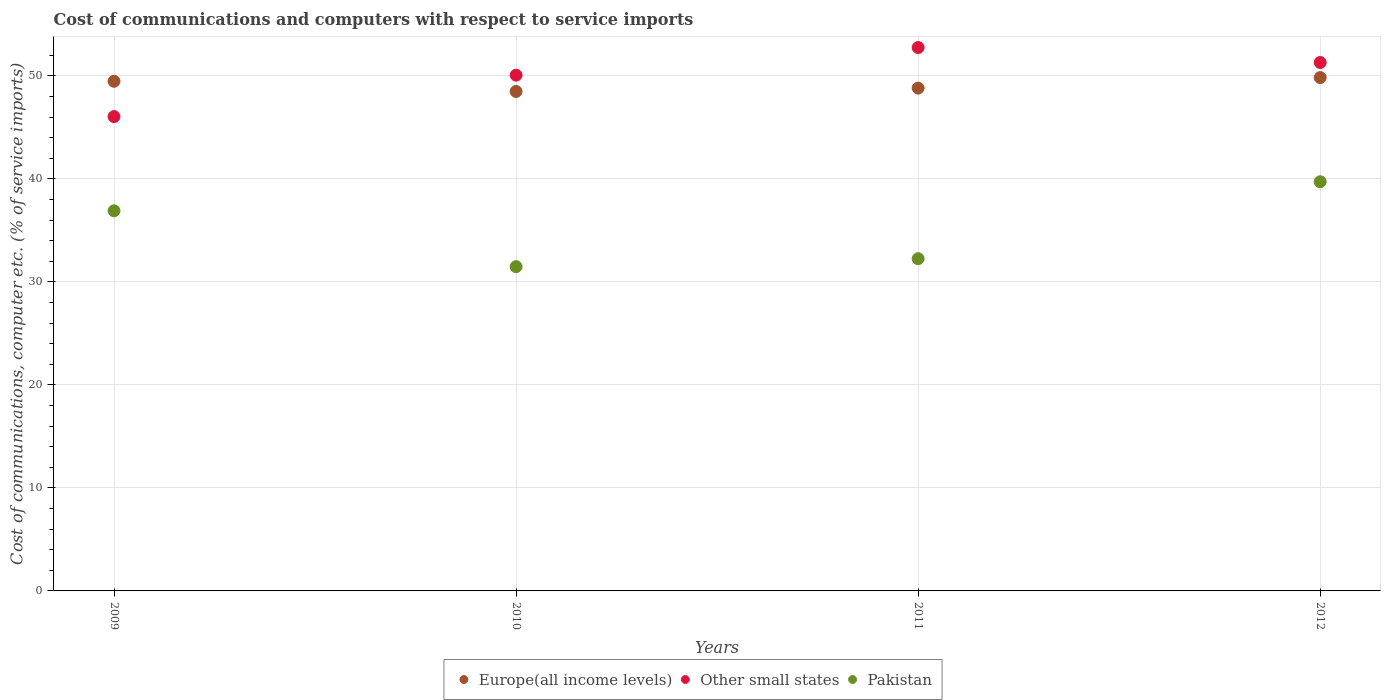Is the number of dotlines equal to the number of legend labels?
Your answer should be very brief. Yes. What is the cost of communications and computers in Other small states in 2010?
Your response must be concise. 50.07. Across all years, what is the maximum cost of communications and computers in Pakistan?
Make the answer very short. 39.73. Across all years, what is the minimum cost of communications and computers in Pakistan?
Make the answer very short. 31.48. In which year was the cost of communications and computers in Europe(all income levels) maximum?
Your response must be concise. 2012. What is the total cost of communications and computers in Other small states in the graph?
Offer a very short reply. 200.19. What is the difference between the cost of communications and computers in Europe(all income levels) in 2011 and that in 2012?
Ensure brevity in your answer.  -1.02. What is the difference between the cost of communications and computers in Other small states in 2010 and the cost of communications and computers in Europe(all income levels) in 2012?
Provide a succinct answer. 0.23. What is the average cost of communications and computers in Pakistan per year?
Your answer should be very brief. 35.09. In the year 2010, what is the difference between the cost of communications and computers in Europe(all income levels) and cost of communications and computers in Other small states?
Provide a short and direct response. -1.58. In how many years, is the cost of communications and computers in Europe(all income levels) greater than 20 %?
Offer a very short reply. 4. What is the ratio of the cost of communications and computers in Europe(all income levels) in 2010 to that in 2011?
Keep it short and to the point. 0.99. What is the difference between the highest and the second highest cost of communications and computers in Other small states?
Your answer should be very brief. 1.45. What is the difference between the highest and the lowest cost of communications and computers in Pakistan?
Offer a very short reply. 8.24. Is it the case that in every year, the sum of the cost of communications and computers in Europe(all income levels) and cost of communications and computers in Other small states  is greater than the cost of communications and computers in Pakistan?
Provide a succinct answer. Yes. Is the cost of communications and computers in Europe(all income levels) strictly less than the cost of communications and computers in Other small states over the years?
Your response must be concise. No. What is the difference between two consecutive major ticks on the Y-axis?
Provide a short and direct response. 10. Are the values on the major ticks of Y-axis written in scientific E-notation?
Ensure brevity in your answer.  No. Does the graph contain any zero values?
Offer a terse response. No. How many legend labels are there?
Give a very brief answer. 3. What is the title of the graph?
Provide a short and direct response. Cost of communications and computers with respect to service imports. Does "Ghana" appear as one of the legend labels in the graph?
Offer a terse response. No. What is the label or title of the X-axis?
Keep it short and to the point. Years. What is the label or title of the Y-axis?
Your answer should be compact. Cost of communications, computer etc. (% of service imports). What is the Cost of communications, computer etc. (% of service imports) in Europe(all income levels) in 2009?
Keep it short and to the point. 49.48. What is the Cost of communications, computer etc. (% of service imports) in Other small states in 2009?
Your response must be concise. 46.05. What is the Cost of communications, computer etc. (% of service imports) in Pakistan in 2009?
Offer a very short reply. 36.91. What is the Cost of communications, computer etc. (% of service imports) of Europe(all income levels) in 2010?
Ensure brevity in your answer.  48.49. What is the Cost of communications, computer etc. (% of service imports) in Other small states in 2010?
Your answer should be compact. 50.07. What is the Cost of communications, computer etc. (% of service imports) of Pakistan in 2010?
Make the answer very short. 31.48. What is the Cost of communications, computer etc. (% of service imports) of Europe(all income levels) in 2011?
Your answer should be very brief. 48.82. What is the Cost of communications, computer etc. (% of service imports) in Other small states in 2011?
Ensure brevity in your answer.  52.76. What is the Cost of communications, computer etc. (% of service imports) of Pakistan in 2011?
Offer a terse response. 32.26. What is the Cost of communications, computer etc. (% of service imports) of Europe(all income levels) in 2012?
Your answer should be very brief. 49.84. What is the Cost of communications, computer etc. (% of service imports) in Other small states in 2012?
Offer a terse response. 51.31. What is the Cost of communications, computer etc. (% of service imports) of Pakistan in 2012?
Your answer should be very brief. 39.73. Across all years, what is the maximum Cost of communications, computer etc. (% of service imports) of Europe(all income levels)?
Ensure brevity in your answer.  49.84. Across all years, what is the maximum Cost of communications, computer etc. (% of service imports) of Other small states?
Your answer should be compact. 52.76. Across all years, what is the maximum Cost of communications, computer etc. (% of service imports) in Pakistan?
Your answer should be compact. 39.73. Across all years, what is the minimum Cost of communications, computer etc. (% of service imports) in Europe(all income levels)?
Offer a terse response. 48.49. Across all years, what is the minimum Cost of communications, computer etc. (% of service imports) in Other small states?
Keep it short and to the point. 46.05. Across all years, what is the minimum Cost of communications, computer etc. (% of service imports) of Pakistan?
Your response must be concise. 31.48. What is the total Cost of communications, computer etc. (% of service imports) of Europe(all income levels) in the graph?
Offer a terse response. 196.64. What is the total Cost of communications, computer etc. (% of service imports) in Other small states in the graph?
Ensure brevity in your answer.  200.19. What is the total Cost of communications, computer etc. (% of service imports) of Pakistan in the graph?
Your response must be concise. 140.38. What is the difference between the Cost of communications, computer etc. (% of service imports) of Europe(all income levels) in 2009 and that in 2010?
Keep it short and to the point. 0.99. What is the difference between the Cost of communications, computer etc. (% of service imports) of Other small states in 2009 and that in 2010?
Provide a short and direct response. -4.02. What is the difference between the Cost of communications, computer etc. (% of service imports) in Pakistan in 2009 and that in 2010?
Provide a succinct answer. 5.42. What is the difference between the Cost of communications, computer etc. (% of service imports) in Europe(all income levels) in 2009 and that in 2011?
Keep it short and to the point. 0.66. What is the difference between the Cost of communications, computer etc. (% of service imports) of Other small states in 2009 and that in 2011?
Your answer should be compact. -6.7. What is the difference between the Cost of communications, computer etc. (% of service imports) of Pakistan in 2009 and that in 2011?
Make the answer very short. 4.65. What is the difference between the Cost of communications, computer etc. (% of service imports) in Europe(all income levels) in 2009 and that in 2012?
Your answer should be very brief. -0.36. What is the difference between the Cost of communications, computer etc. (% of service imports) in Other small states in 2009 and that in 2012?
Provide a succinct answer. -5.25. What is the difference between the Cost of communications, computer etc. (% of service imports) of Pakistan in 2009 and that in 2012?
Provide a succinct answer. -2.82. What is the difference between the Cost of communications, computer etc. (% of service imports) in Europe(all income levels) in 2010 and that in 2011?
Provide a short and direct response. -0.33. What is the difference between the Cost of communications, computer etc. (% of service imports) of Other small states in 2010 and that in 2011?
Provide a succinct answer. -2.68. What is the difference between the Cost of communications, computer etc. (% of service imports) of Pakistan in 2010 and that in 2011?
Keep it short and to the point. -0.77. What is the difference between the Cost of communications, computer etc. (% of service imports) of Europe(all income levels) in 2010 and that in 2012?
Make the answer very short. -1.35. What is the difference between the Cost of communications, computer etc. (% of service imports) in Other small states in 2010 and that in 2012?
Give a very brief answer. -1.23. What is the difference between the Cost of communications, computer etc. (% of service imports) in Pakistan in 2010 and that in 2012?
Offer a terse response. -8.24. What is the difference between the Cost of communications, computer etc. (% of service imports) in Europe(all income levels) in 2011 and that in 2012?
Offer a terse response. -1.02. What is the difference between the Cost of communications, computer etc. (% of service imports) in Other small states in 2011 and that in 2012?
Offer a very short reply. 1.45. What is the difference between the Cost of communications, computer etc. (% of service imports) in Pakistan in 2011 and that in 2012?
Keep it short and to the point. -7.47. What is the difference between the Cost of communications, computer etc. (% of service imports) of Europe(all income levels) in 2009 and the Cost of communications, computer etc. (% of service imports) of Other small states in 2010?
Your response must be concise. -0.59. What is the difference between the Cost of communications, computer etc. (% of service imports) in Europe(all income levels) in 2009 and the Cost of communications, computer etc. (% of service imports) in Pakistan in 2010?
Offer a terse response. 18. What is the difference between the Cost of communications, computer etc. (% of service imports) in Other small states in 2009 and the Cost of communications, computer etc. (% of service imports) in Pakistan in 2010?
Make the answer very short. 14.57. What is the difference between the Cost of communications, computer etc. (% of service imports) in Europe(all income levels) in 2009 and the Cost of communications, computer etc. (% of service imports) in Other small states in 2011?
Offer a very short reply. -3.28. What is the difference between the Cost of communications, computer etc. (% of service imports) in Europe(all income levels) in 2009 and the Cost of communications, computer etc. (% of service imports) in Pakistan in 2011?
Give a very brief answer. 17.22. What is the difference between the Cost of communications, computer etc. (% of service imports) of Other small states in 2009 and the Cost of communications, computer etc. (% of service imports) of Pakistan in 2011?
Make the answer very short. 13.8. What is the difference between the Cost of communications, computer etc. (% of service imports) in Europe(all income levels) in 2009 and the Cost of communications, computer etc. (% of service imports) in Other small states in 2012?
Keep it short and to the point. -1.82. What is the difference between the Cost of communications, computer etc. (% of service imports) of Europe(all income levels) in 2009 and the Cost of communications, computer etc. (% of service imports) of Pakistan in 2012?
Ensure brevity in your answer.  9.75. What is the difference between the Cost of communications, computer etc. (% of service imports) of Other small states in 2009 and the Cost of communications, computer etc. (% of service imports) of Pakistan in 2012?
Your answer should be very brief. 6.32. What is the difference between the Cost of communications, computer etc. (% of service imports) in Europe(all income levels) in 2010 and the Cost of communications, computer etc. (% of service imports) in Other small states in 2011?
Offer a very short reply. -4.27. What is the difference between the Cost of communications, computer etc. (% of service imports) of Europe(all income levels) in 2010 and the Cost of communications, computer etc. (% of service imports) of Pakistan in 2011?
Provide a short and direct response. 16.24. What is the difference between the Cost of communications, computer etc. (% of service imports) of Other small states in 2010 and the Cost of communications, computer etc. (% of service imports) of Pakistan in 2011?
Provide a succinct answer. 17.82. What is the difference between the Cost of communications, computer etc. (% of service imports) of Europe(all income levels) in 2010 and the Cost of communications, computer etc. (% of service imports) of Other small states in 2012?
Provide a succinct answer. -2.81. What is the difference between the Cost of communications, computer etc. (% of service imports) in Europe(all income levels) in 2010 and the Cost of communications, computer etc. (% of service imports) in Pakistan in 2012?
Ensure brevity in your answer.  8.76. What is the difference between the Cost of communications, computer etc. (% of service imports) in Other small states in 2010 and the Cost of communications, computer etc. (% of service imports) in Pakistan in 2012?
Make the answer very short. 10.35. What is the difference between the Cost of communications, computer etc. (% of service imports) of Europe(all income levels) in 2011 and the Cost of communications, computer etc. (% of service imports) of Other small states in 2012?
Offer a terse response. -2.49. What is the difference between the Cost of communications, computer etc. (% of service imports) of Europe(all income levels) in 2011 and the Cost of communications, computer etc. (% of service imports) of Pakistan in 2012?
Provide a succinct answer. 9.09. What is the difference between the Cost of communications, computer etc. (% of service imports) of Other small states in 2011 and the Cost of communications, computer etc. (% of service imports) of Pakistan in 2012?
Your answer should be compact. 13.03. What is the average Cost of communications, computer etc. (% of service imports) of Europe(all income levels) per year?
Give a very brief answer. 49.16. What is the average Cost of communications, computer etc. (% of service imports) of Other small states per year?
Ensure brevity in your answer.  50.05. What is the average Cost of communications, computer etc. (% of service imports) in Pakistan per year?
Your response must be concise. 35.09. In the year 2009, what is the difference between the Cost of communications, computer etc. (% of service imports) in Europe(all income levels) and Cost of communications, computer etc. (% of service imports) in Other small states?
Keep it short and to the point. 3.43. In the year 2009, what is the difference between the Cost of communications, computer etc. (% of service imports) in Europe(all income levels) and Cost of communications, computer etc. (% of service imports) in Pakistan?
Keep it short and to the point. 12.58. In the year 2009, what is the difference between the Cost of communications, computer etc. (% of service imports) of Other small states and Cost of communications, computer etc. (% of service imports) of Pakistan?
Your response must be concise. 9.15. In the year 2010, what is the difference between the Cost of communications, computer etc. (% of service imports) in Europe(all income levels) and Cost of communications, computer etc. (% of service imports) in Other small states?
Your answer should be compact. -1.58. In the year 2010, what is the difference between the Cost of communications, computer etc. (% of service imports) in Europe(all income levels) and Cost of communications, computer etc. (% of service imports) in Pakistan?
Your answer should be very brief. 17.01. In the year 2010, what is the difference between the Cost of communications, computer etc. (% of service imports) of Other small states and Cost of communications, computer etc. (% of service imports) of Pakistan?
Keep it short and to the point. 18.59. In the year 2011, what is the difference between the Cost of communications, computer etc. (% of service imports) in Europe(all income levels) and Cost of communications, computer etc. (% of service imports) in Other small states?
Offer a very short reply. -3.94. In the year 2011, what is the difference between the Cost of communications, computer etc. (% of service imports) of Europe(all income levels) and Cost of communications, computer etc. (% of service imports) of Pakistan?
Provide a short and direct response. 16.56. In the year 2011, what is the difference between the Cost of communications, computer etc. (% of service imports) of Other small states and Cost of communications, computer etc. (% of service imports) of Pakistan?
Your answer should be compact. 20.5. In the year 2012, what is the difference between the Cost of communications, computer etc. (% of service imports) in Europe(all income levels) and Cost of communications, computer etc. (% of service imports) in Other small states?
Ensure brevity in your answer.  -1.46. In the year 2012, what is the difference between the Cost of communications, computer etc. (% of service imports) of Europe(all income levels) and Cost of communications, computer etc. (% of service imports) of Pakistan?
Your answer should be compact. 10.11. In the year 2012, what is the difference between the Cost of communications, computer etc. (% of service imports) in Other small states and Cost of communications, computer etc. (% of service imports) in Pakistan?
Provide a succinct answer. 11.58. What is the ratio of the Cost of communications, computer etc. (% of service imports) in Europe(all income levels) in 2009 to that in 2010?
Your answer should be compact. 1.02. What is the ratio of the Cost of communications, computer etc. (% of service imports) of Other small states in 2009 to that in 2010?
Give a very brief answer. 0.92. What is the ratio of the Cost of communications, computer etc. (% of service imports) of Pakistan in 2009 to that in 2010?
Your answer should be compact. 1.17. What is the ratio of the Cost of communications, computer etc. (% of service imports) in Europe(all income levels) in 2009 to that in 2011?
Give a very brief answer. 1.01. What is the ratio of the Cost of communications, computer etc. (% of service imports) of Other small states in 2009 to that in 2011?
Keep it short and to the point. 0.87. What is the ratio of the Cost of communications, computer etc. (% of service imports) in Pakistan in 2009 to that in 2011?
Your response must be concise. 1.14. What is the ratio of the Cost of communications, computer etc. (% of service imports) in Other small states in 2009 to that in 2012?
Offer a terse response. 0.9. What is the ratio of the Cost of communications, computer etc. (% of service imports) of Pakistan in 2009 to that in 2012?
Your answer should be very brief. 0.93. What is the ratio of the Cost of communications, computer etc. (% of service imports) of Europe(all income levels) in 2010 to that in 2011?
Your answer should be compact. 0.99. What is the ratio of the Cost of communications, computer etc. (% of service imports) in Other small states in 2010 to that in 2011?
Offer a terse response. 0.95. What is the ratio of the Cost of communications, computer etc. (% of service imports) of Europe(all income levels) in 2010 to that in 2012?
Offer a terse response. 0.97. What is the ratio of the Cost of communications, computer etc. (% of service imports) in Other small states in 2010 to that in 2012?
Give a very brief answer. 0.98. What is the ratio of the Cost of communications, computer etc. (% of service imports) of Pakistan in 2010 to that in 2012?
Make the answer very short. 0.79. What is the ratio of the Cost of communications, computer etc. (% of service imports) in Europe(all income levels) in 2011 to that in 2012?
Your answer should be compact. 0.98. What is the ratio of the Cost of communications, computer etc. (% of service imports) of Other small states in 2011 to that in 2012?
Provide a succinct answer. 1.03. What is the ratio of the Cost of communications, computer etc. (% of service imports) of Pakistan in 2011 to that in 2012?
Give a very brief answer. 0.81. What is the difference between the highest and the second highest Cost of communications, computer etc. (% of service imports) of Europe(all income levels)?
Ensure brevity in your answer.  0.36. What is the difference between the highest and the second highest Cost of communications, computer etc. (% of service imports) of Other small states?
Ensure brevity in your answer.  1.45. What is the difference between the highest and the second highest Cost of communications, computer etc. (% of service imports) in Pakistan?
Provide a short and direct response. 2.82. What is the difference between the highest and the lowest Cost of communications, computer etc. (% of service imports) of Europe(all income levels)?
Ensure brevity in your answer.  1.35. What is the difference between the highest and the lowest Cost of communications, computer etc. (% of service imports) of Other small states?
Make the answer very short. 6.7. What is the difference between the highest and the lowest Cost of communications, computer etc. (% of service imports) of Pakistan?
Offer a terse response. 8.24. 